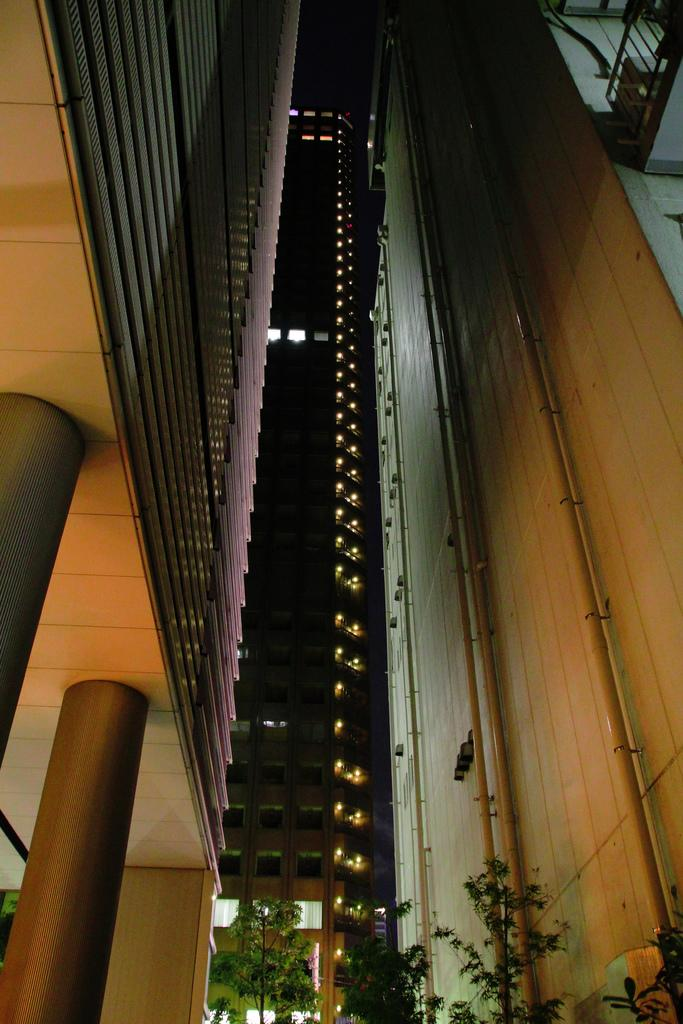What type of structure is visible in the image? There is a building in the image. What architectural features can be seen on the building? The building has pillars and windows. Are there any other elements visible on the building? Yes, there are pipes visible on the building. What else can be seen in the image besides the building? There is a wall and plants in the image. How does the building rub against the plants in the image? The building does not rub against the plants in the image; they are separate elements in the scene. 